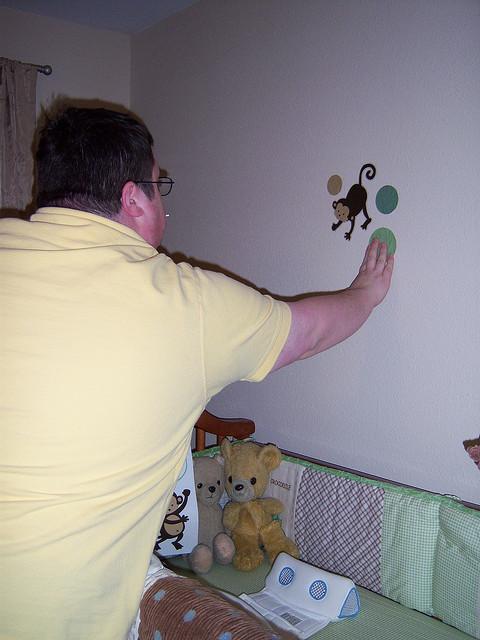Is the man wearing glasses?
Short answer required. Yes. What animals are in the nursery?
Write a very short answer. Monkeys and bears. Is this in a home or hotel?
Short answer required. Home. What is the man touching?
Keep it brief. Wall. Are the bears hugging the baby?
Answer briefly. No. 